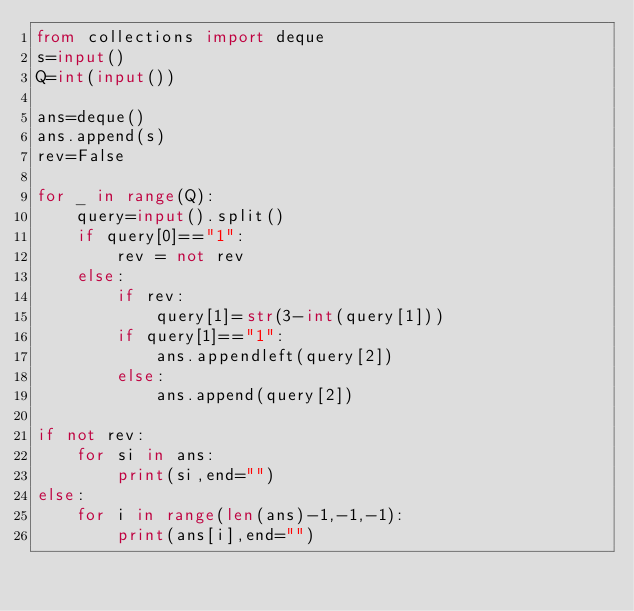Convert code to text. <code><loc_0><loc_0><loc_500><loc_500><_Python_>from collections import deque
s=input()
Q=int(input())

ans=deque()
ans.append(s)
rev=False

for _ in range(Q):
    query=input().split()
    if query[0]=="1":
        rev = not rev
    else:
        if rev:
            query[1]=str(3-int(query[1]))
        if query[1]=="1":
            ans.appendleft(query[2])
        else:
            ans.append(query[2])

if not rev:
    for si in ans:
        print(si,end="")
else:
    for i in range(len(ans)-1,-1,-1):
        print(ans[i],end="")
</code> 